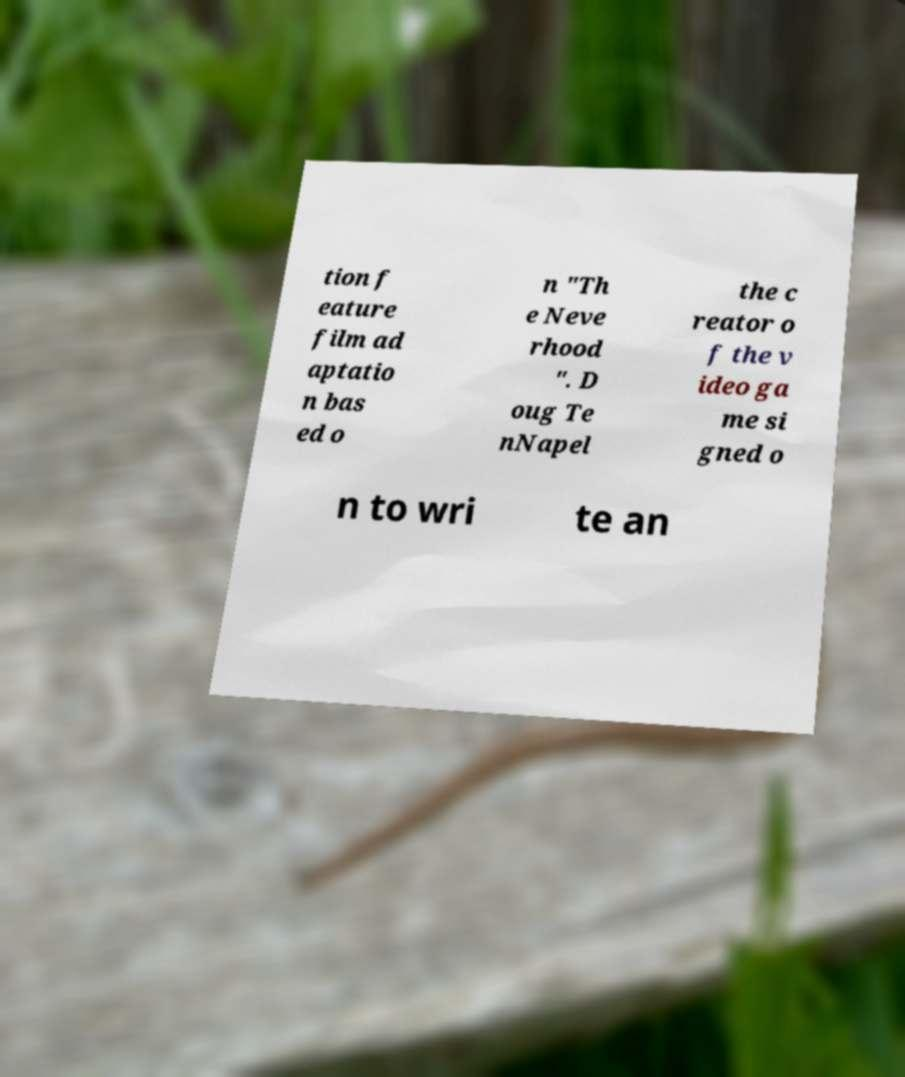For documentation purposes, I need the text within this image transcribed. Could you provide that? tion f eature film ad aptatio n bas ed o n "Th e Neve rhood ". D oug Te nNapel the c reator o f the v ideo ga me si gned o n to wri te an 